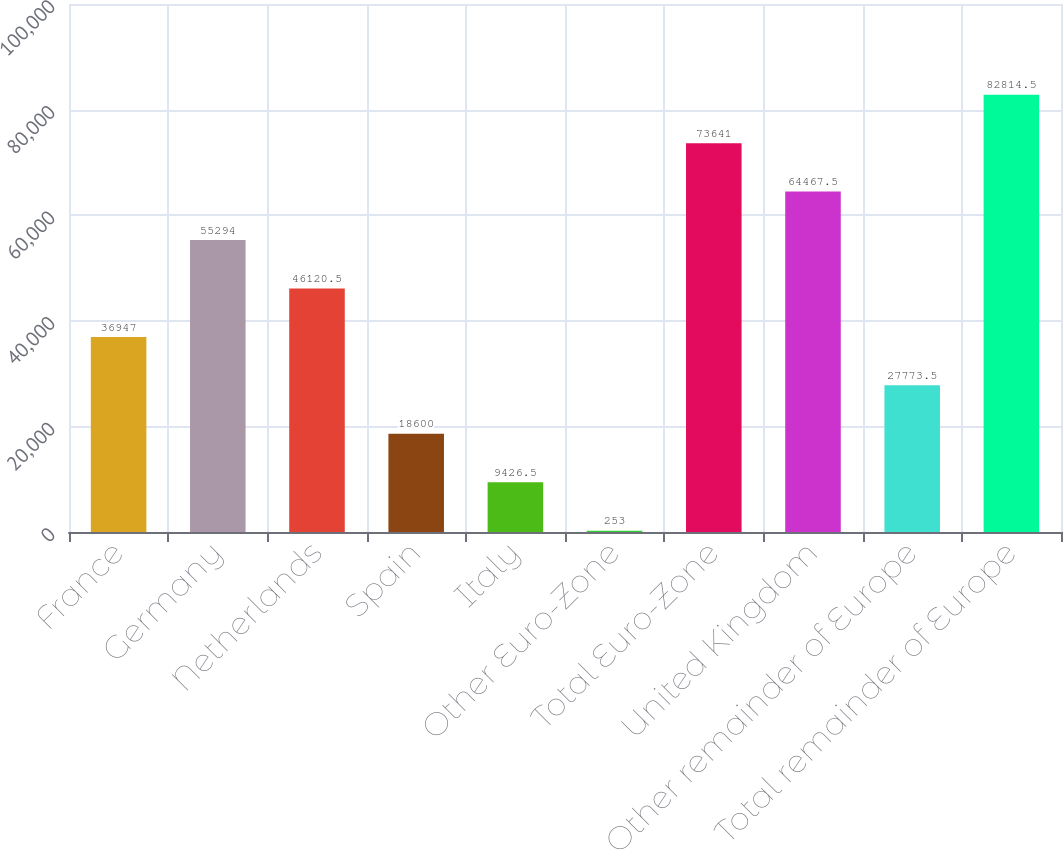<chart> <loc_0><loc_0><loc_500><loc_500><bar_chart><fcel>France<fcel>Germany<fcel>Netherlands<fcel>Spain<fcel>Italy<fcel>Other Euro-Zone<fcel>Total Euro-Zone<fcel>United Kingdom<fcel>Other remainder of Europe<fcel>Total remainder of Europe<nl><fcel>36947<fcel>55294<fcel>46120.5<fcel>18600<fcel>9426.5<fcel>253<fcel>73641<fcel>64467.5<fcel>27773.5<fcel>82814.5<nl></chart> 